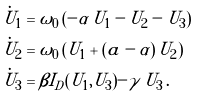<formula> <loc_0><loc_0><loc_500><loc_500>\dot { U } _ { 1 } & = \omega _ { 0 } \left ( - \alpha \, U _ { 1 } - U _ { 2 } - U _ { 3 } \right ) \\ \dot { U } _ { 2 } & = \omega _ { 0 } \left ( U _ { 1 } + ( a - \alpha ) \, U _ { 2 } \right ) \\ \dot { U } _ { 3 } & = \beta I _ { D } ( U _ { 1 } , U _ { 3 } ) - \gamma \, U _ { 3 } \, .</formula> 